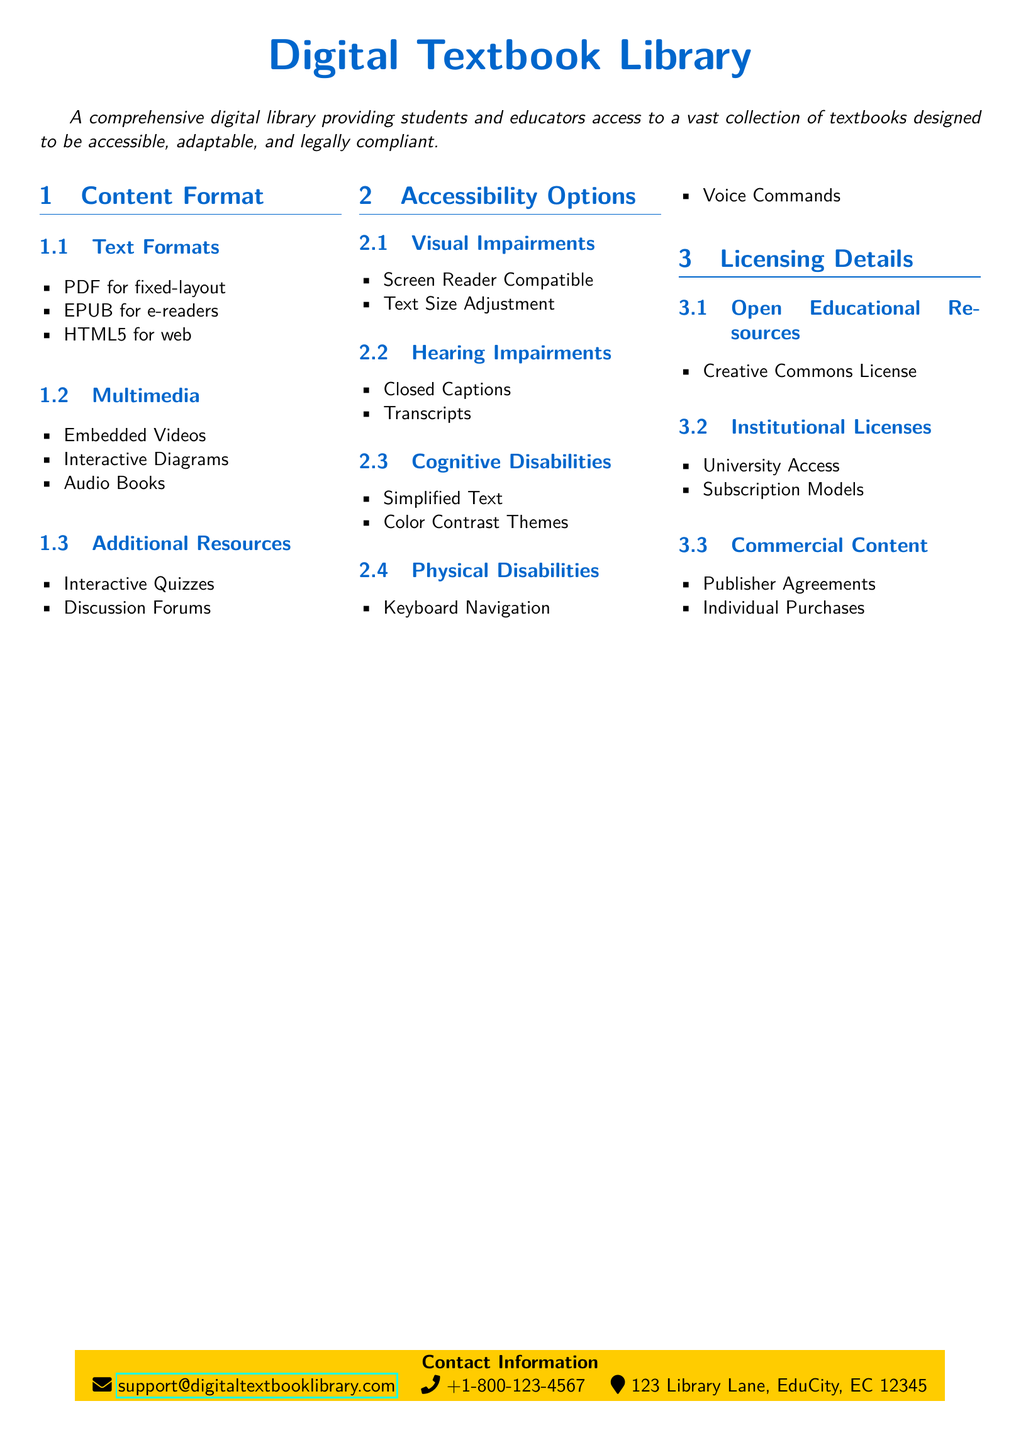what are the text formats available? The document lists the text formats available for the digital textbooks, which are PDF, EPUB, and HTML5.
Answer: PDF, EPUB, HTML5 what multimedia options are included? The document specifies the multimedia options included in the digital textbook library, such as Embedded Videos, Interactive Diagrams, and Audio Books.
Answer: Embedded Videos, Interactive Diagrams, Audio Books how many accessibility options are listed for visual impairments? The document provides two accessibility options specifically for visual impairments described in the section.
Answer: 2 what is the licensing type for Open Educational Resources? The document states the licensing type for Open Educational Resources is a Creative Commons License.
Answer: Creative Commons License what accessibility feature is available for cognitive disabilities? The document mentions Simplified Text and Color Contrast Themes as features for cognitive disabilities.
Answer: Simplified Text, Color Contrast Themes how can users contact the digital textbook library support? The document provides contact information including an email address, phone number, and physical address.
Answer: support@digitaltextbooklibrary.com, +1-800-123-4567, 123 Library Lane, EduCity, EC 12345 what kind of licenses are available for institutional use? The document states that Institutional Licenses include University Access and Subscription Models.
Answer: University Access, Subscription Models how many options are provided for hearing impairments? The document lists two options for hearing impairments related to accessibility features.
Answer: 2 which format is specifically for e-readers? The document identifies a specific format designed for e-readers in the text formats section.
Answer: EPUB 